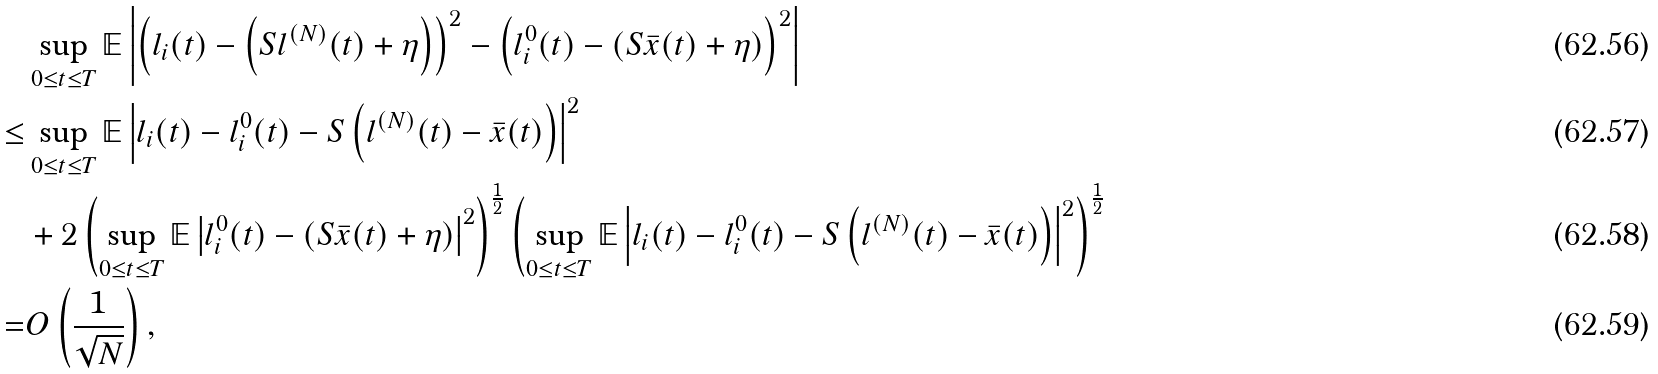Convert formula to latex. <formula><loc_0><loc_0><loc_500><loc_500>& \sup _ { 0 \leq t \leq T } \mathbb { E } \left | \left ( l _ { i } ( t ) - \left ( S l ^ { ( N ) } ( t ) + \eta \right ) \right ) ^ { 2 } - \left ( l ^ { 0 } _ { i } ( t ) - \left ( S \bar { x } ( t ) + \eta \right ) \right ) ^ { 2 } \right | \\ \leq & \sup _ { 0 \leq t \leq T } \mathbb { E } \left | l _ { i } ( t ) - l ^ { 0 } _ { i } ( t ) - S \left ( l ^ { ( N ) } ( t ) - \bar { x } ( t ) \right ) \right | ^ { 2 } \\ & + 2 \left ( \sup _ { 0 \leq t \leq T } \mathbb { E } \left | l ^ { 0 } _ { i } ( t ) - \left ( S \bar { x } ( t ) + \eta \right ) \right | ^ { 2 } \right ) ^ { \frac { 1 } { 2 } } \left ( \sup _ { 0 \leq t \leq T } \mathbb { E } \left | l _ { i } ( t ) - l ^ { 0 } _ { i } ( t ) - S \left ( l ^ { ( N ) } ( t ) - \bar { x } ( t ) \right ) \right | ^ { 2 } \right ) ^ { \frac { 1 } { 2 } } \\ = & O \left ( \frac { 1 } { \sqrt { N } } \right ) ,</formula> 